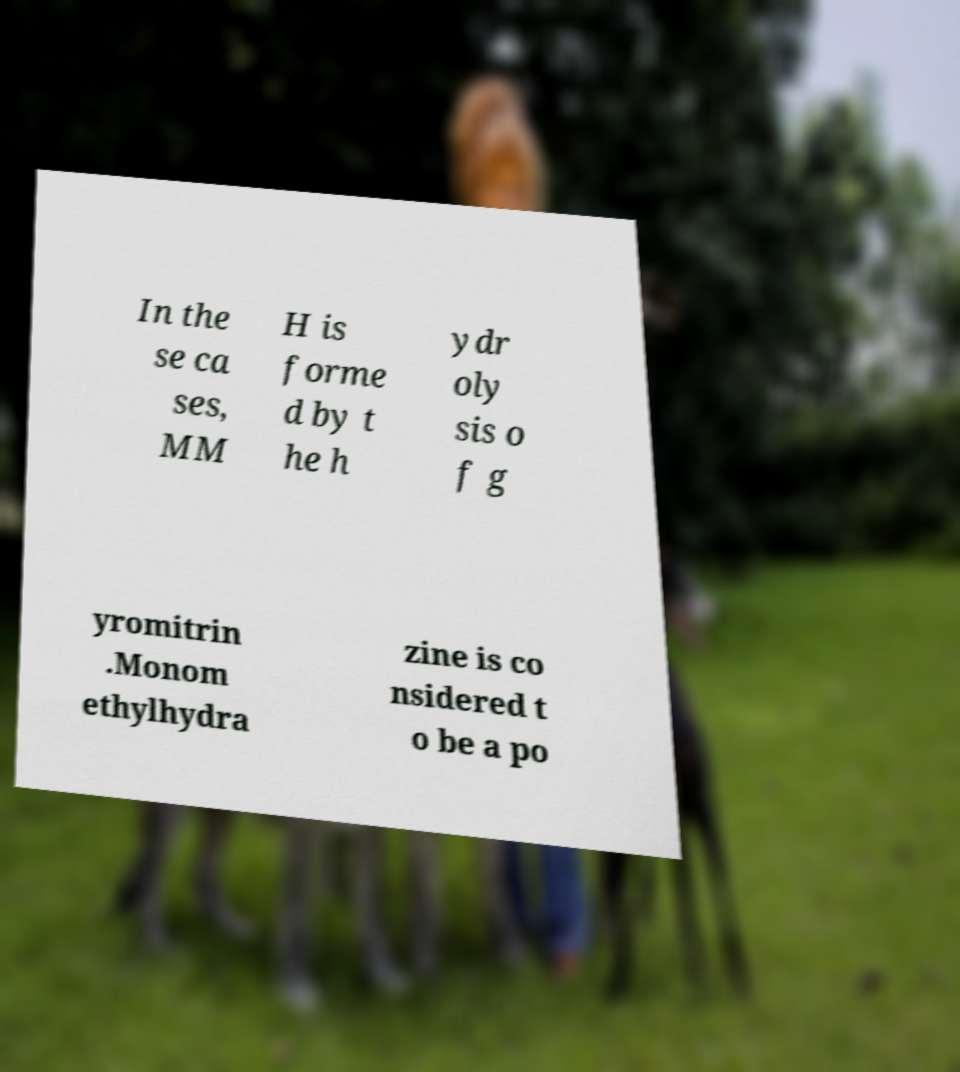Please identify and transcribe the text found in this image. In the se ca ses, MM H is forme d by t he h ydr oly sis o f g yromitrin .Monom ethylhydra zine is co nsidered t o be a po 